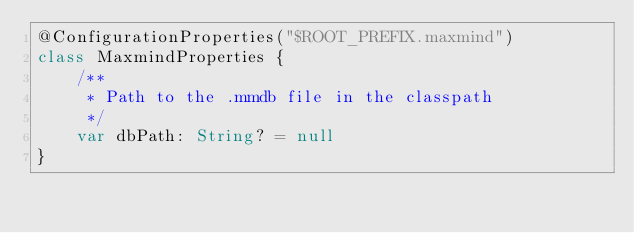<code> <loc_0><loc_0><loc_500><loc_500><_Kotlin_>@ConfigurationProperties("$ROOT_PREFIX.maxmind")
class MaxmindProperties {
    /**
     * Path to the .mmdb file in the classpath
     */
    var dbPath: String? = null
}</code> 